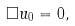Convert formula to latex. <formula><loc_0><loc_0><loc_500><loc_500>\Box u _ { 0 } = 0 ,</formula> 